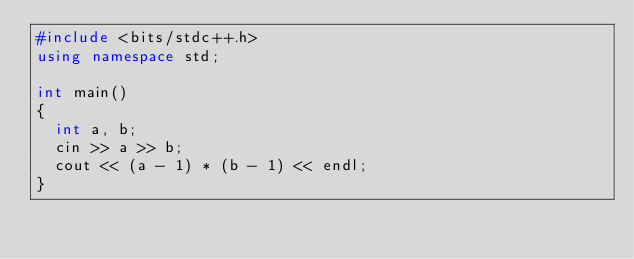<code> <loc_0><loc_0><loc_500><loc_500><_C++_>#include <bits/stdc++.h>
using namespace std;

int main()
{
  int a, b;
  cin >> a >> b;
  cout << (a - 1) * (b - 1) << endl;
}
</code> 